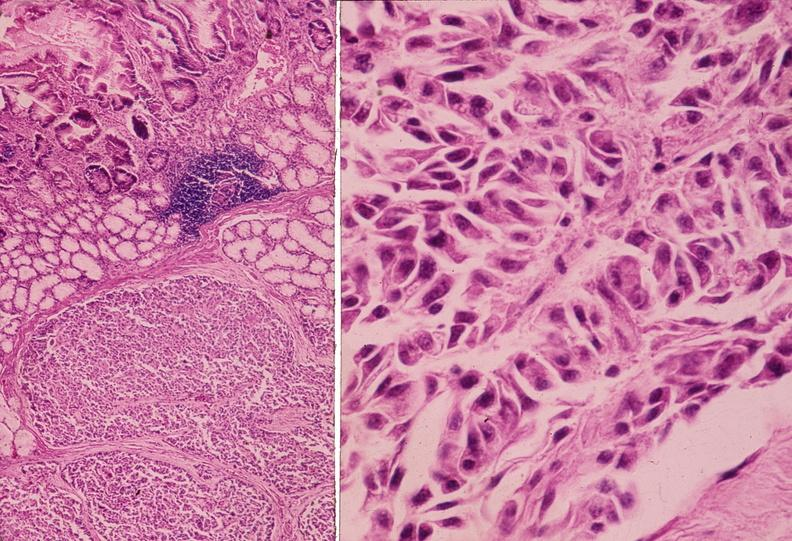s pancreas present?
Answer the question using a single word or phrase. Yes 